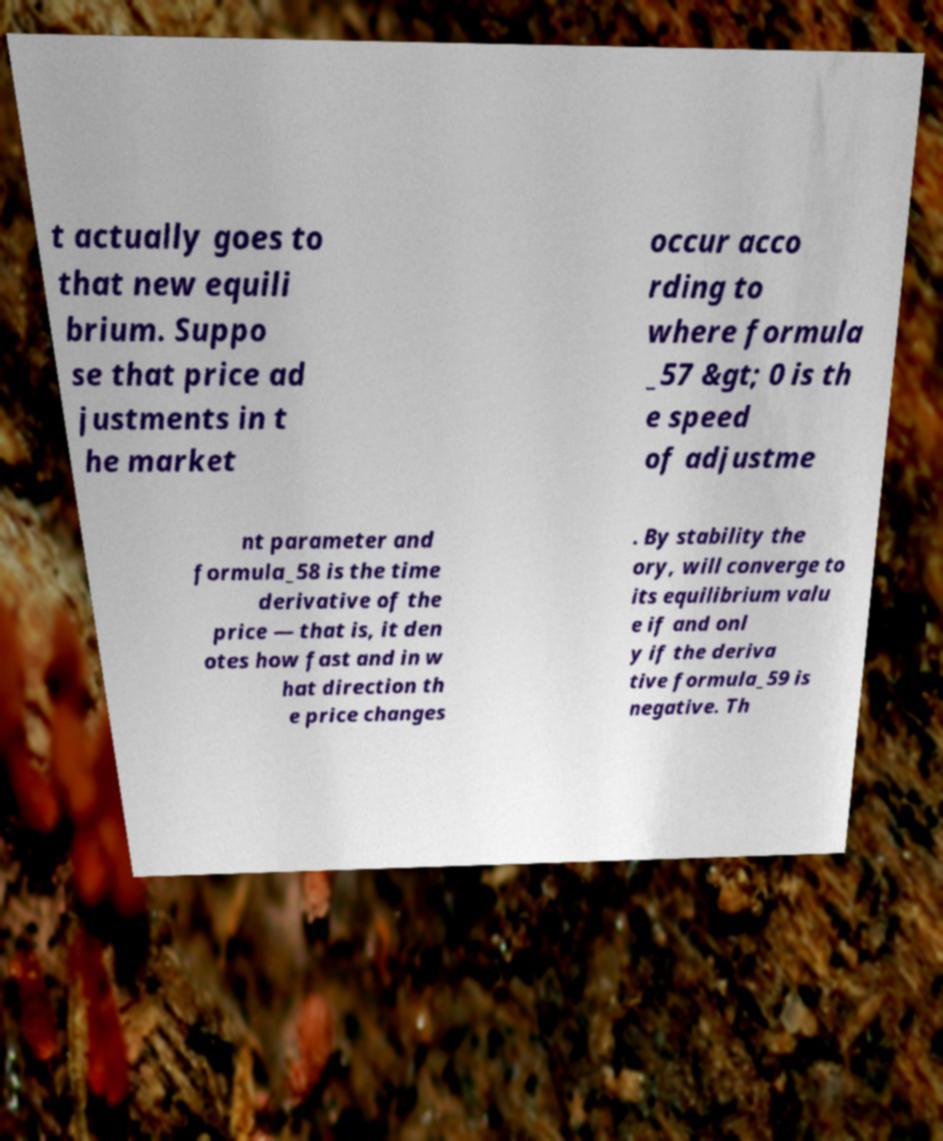Can you accurately transcribe the text from the provided image for me? t actually goes to that new equili brium. Suppo se that price ad justments in t he market occur acco rding to where formula _57 &gt; 0 is th e speed of adjustme nt parameter and formula_58 is the time derivative of the price — that is, it den otes how fast and in w hat direction th e price changes . By stability the ory, will converge to its equilibrium valu e if and onl y if the deriva tive formula_59 is negative. Th 